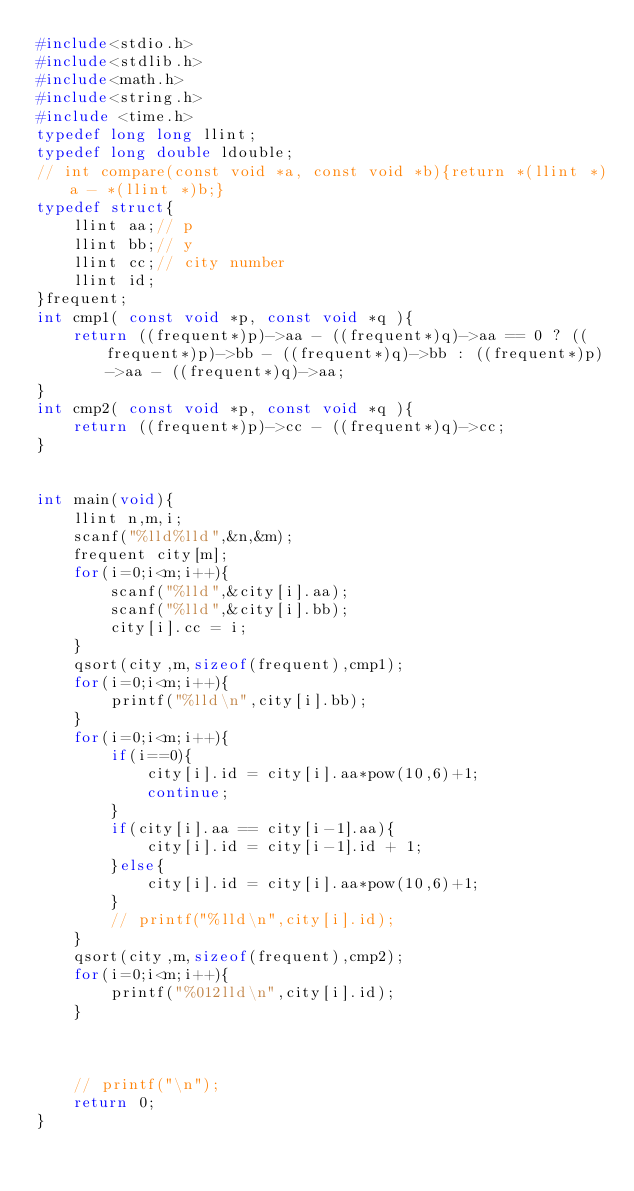<code> <loc_0><loc_0><loc_500><loc_500><_C_>#include<stdio.h>
#include<stdlib.h>
#include<math.h>
#include<string.h>
#include <time.h>
typedef long long llint;
typedef long double ldouble;
// int compare(const void *a, const void *b){return *(llint *)a - *(llint *)b;}
typedef struct{
    llint aa;// p
    llint bb;// y 
    llint cc;// city number
    llint id;
}frequent;
int cmp1( const void *p, const void *q ){
    return ((frequent*)p)->aa - ((frequent*)q)->aa == 0 ? ((frequent*)p)->bb - ((frequent*)q)->bb : ((frequent*)p)->aa - ((frequent*)q)->aa;
}
int cmp2( const void *p, const void *q ){
    return ((frequent*)p)->cc - ((frequent*)q)->cc;
}


int main(void){
    llint n,m,i;
    scanf("%lld%lld",&n,&m);
    frequent city[m];
    for(i=0;i<m;i++){
        scanf("%lld",&city[i].aa);
        scanf("%lld",&city[i].bb);
        city[i].cc = i;
    }
    qsort(city,m,sizeof(frequent),cmp1);
    for(i=0;i<m;i++){
        printf("%lld\n",city[i].bb);
    }
    for(i=0;i<m;i++){
        if(i==0){
            city[i].id = city[i].aa*pow(10,6)+1;
            continue;
        }
        if(city[i].aa == city[i-1].aa){
            city[i].id = city[i-1].id + 1;
        }else{
            city[i].id = city[i].aa*pow(10,6)+1;
        }
        // printf("%lld\n",city[i].id);
    }
    qsort(city,m,sizeof(frequent),cmp2);
    for(i=0;i<m;i++){
        printf("%012lld\n",city[i].id);
    }



    // printf("\n");
    return 0;
}
</code> 